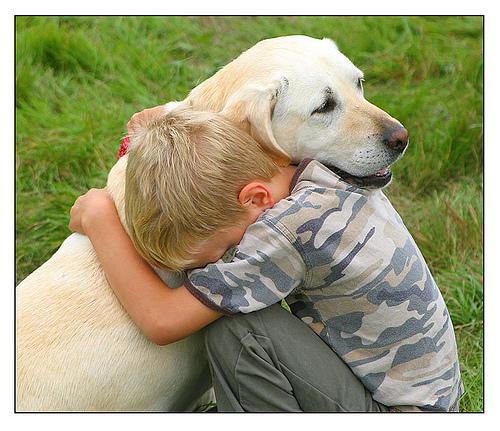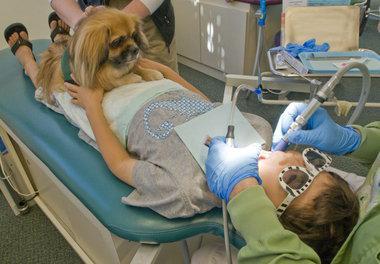The first image is the image on the left, the second image is the image on the right. Given the left and right images, does the statement "One image shows a person in a pony-tail with head bent toward a dog, and the other image shows a male in an olive jacket with head next to a dog." hold true? Answer yes or no. No. 